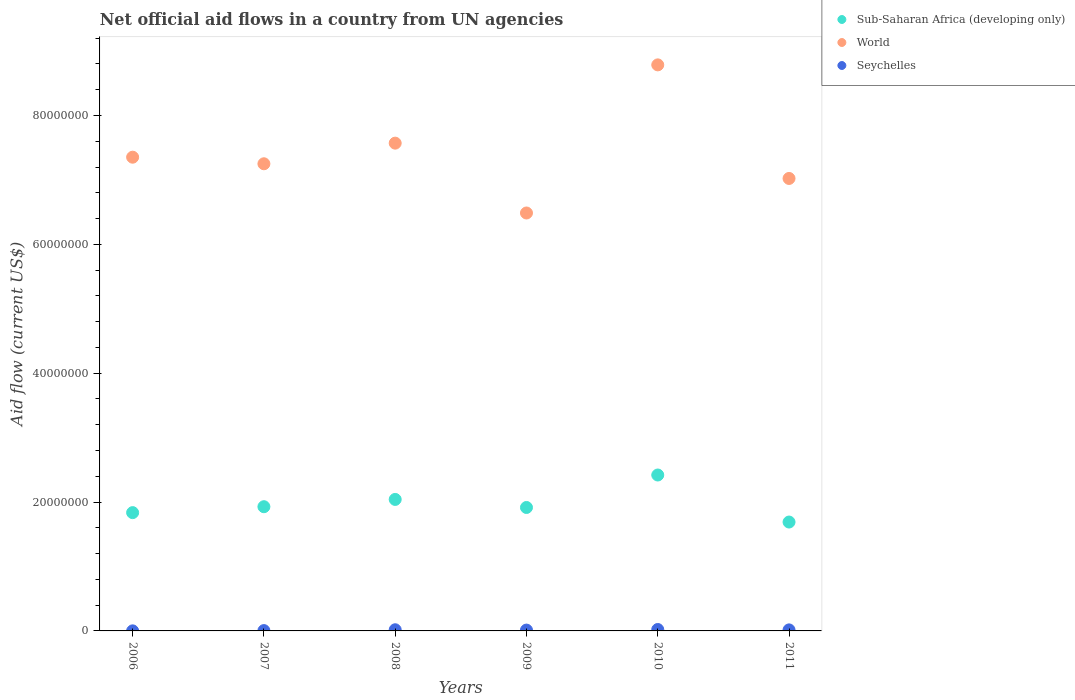How many different coloured dotlines are there?
Provide a succinct answer. 3. Is the number of dotlines equal to the number of legend labels?
Provide a succinct answer. Yes. What is the net official aid flow in World in 2011?
Give a very brief answer. 7.02e+07. Across all years, what is the maximum net official aid flow in Seychelles?
Your answer should be compact. 2.20e+05. Across all years, what is the minimum net official aid flow in Sub-Saharan Africa (developing only)?
Make the answer very short. 1.69e+07. In which year was the net official aid flow in Seychelles minimum?
Ensure brevity in your answer.  2006. What is the total net official aid flow in Seychelles in the graph?
Provide a short and direct response. 7.50e+05. What is the difference between the net official aid flow in Sub-Saharan Africa (developing only) in 2006 and that in 2009?
Your answer should be compact. -8.00e+05. What is the difference between the net official aid flow in Seychelles in 2006 and the net official aid flow in World in 2011?
Your answer should be very brief. -7.02e+07. What is the average net official aid flow in Sub-Saharan Africa (developing only) per year?
Your response must be concise. 1.97e+07. In the year 2011, what is the difference between the net official aid flow in Seychelles and net official aid flow in Sub-Saharan Africa (developing only)?
Your answer should be very brief. -1.67e+07. In how many years, is the net official aid flow in World greater than 84000000 US$?
Provide a short and direct response. 1. What is the ratio of the net official aid flow in Seychelles in 2009 to that in 2011?
Your answer should be compact. 0.81. What is the difference between the highest and the second highest net official aid flow in Seychelles?
Keep it short and to the point. 4.00e+04. What is the difference between the highest and the lowest net official aid flow in World?
Provide a short and direct response. 2.30e+07. Is it the case that in every year, the sum of the net official aid flow in World and net official aid flow in Seychelles  is greater than the net official aid flow in Sub-Saharan Africa (developing only)?
Provide a short and direct response. Yes. Is the net official aid flow in World strictly less than the net official aid flow in Sub-Saharan Africa (developing only) over the years?
Your response must be concise. No. How many dotlines are there?
Your response must be concise. 3. What is the difference between two consecutive major ticks on the Y-axis?
Give a very brief answer. 2.00e+07. Are the values on the major ticks of Y-axis written in scientific E-notation?
Give a very brief answer. No. Does the graph contain grids?
Offer a terse response. No. How many legend labels are there?
Provide a succinct answer. 3. How are the legend labels stacked?
Give a very brief answer. Vertical. What is the title of the graph?
Ensure brevity in your answer.  Net official aid flows in a country from UN agencies. Does "South Africa" appear as one of the legend labels in the graph?
Your answer should be compact. No. What is the label or title of the Y-axis?
Provide a short and direct response. Aid flow (current US$). What is the Aid flow (current US$) of Sub-Saharan Africa (developing only) in 2006?
Your answer should be compact. 1.84e+07. What is the Aid flow (current US$) in World in 2006?
Your answer should be compact. 7.35e+07. What is the Aid flow (current US$) of Sub-Saharan Africa (developing only) in 2007?
Provide a succinct answer. 1.93e+07. What is the Aid flow (current US$) of World in 2007?
Give a very brief answer. 7.25e+07. What is the Aid flow (current US$) in Seychelles in 2007?
Keep it short and to the point. 5.00e+04. What is the Aid flow (current US$) of Sub-Saharan Africa (developing only) in 2008?
Offer a terse response. 2.04e+07. What is the Aid flow (current US$) of World in 2008?
Make the answer very short. 7.57e+07. What is the Aid flow (current US$) of Seychelles in 2008?
Provide a succinct answer. 1.80e+05. What is the Aid flow (current US$) in Sub-Saharan Africa (developing only) in 2009?
Your answer should be very brief. 1.92e+07. What is the Aid flow (current US$) in World in 2009?
Your response must be concise. 6.49e+07. What is the Aid flow (current US$) in Seychelles in 2009?
Offer a terse response. 1.30e+05. What is the Aid flow (current US$) of Sub-Saharan Africa (developing only) in 2010?
Your answer should be compact. 2.42e+07. What is the Aid flow (current US$) of World in 2010?
Provide a short and direct response. 8.79e+07. What is the Aid flow (current US$) in Seychelles in 2010?
Your answer should be compact. 2.20e+05. What is the Aid flow (current US$) of Sub-Saharan Africa (developing only) in 2011?
Your answer should be very brief. 1.69e+07. What is the Aid flow (current US$) in World in 2011?
Offer a very short reply. 7.02e+07. Across all years, what is the maximum Aid flow (current US$) in Sub-Saharan Africa (developing only)?
Give a very brief answer. 2.42e+07. Across all years, what is the maximum Aid flow (current US$) of World?
Your response must be concise. 8.79e+07. Across all years, what is the maximum Aid flow (current US$) of Seychelles?
Offer a terse response. 2.20e+05. Across all years, what is the minimum Aid flow (current US$) of Sub-Saharan Africa (developing only)?
Your answer should be compact. 1.69e+07. Across all years, what is the minimum Aid flow (current US$) of World?
Offer a terse response. 6.49e+07. What is the total Aid flow (current US$) in Sub-Saharan Africa (developing only) in the graph?
Give a very brief answer. 1.18e+08. What is the total Aid flow (current US$) in World in the graph?
Offer a terse response. 4.45e+08. What is the total Aid flow (current US$) of Seychelles in the graph?
Your answer should be very brief. 7.50e+05. What is the difference between the Aid flow (current US$) of Sub-Saharan Africa (developing only) in 2006 and that in 2007?
Provide a short and direct response. -9.20e+05. What is the difference between the Aid flow (current US$) in World in 2006 and that in 2007?
Your response must be concise. 1.02e+06. What is the difference between the Aid flow (current US$) of Sub-Saharan Africa (developing only) in 2006 and that in 2008?
Ensure brevity in your answer.  -2.05e+06. What is the difference between the Aid flow (current US$) in World in 2006 and that in 2008?
Your answer should be very brief. -2.18e+06. What is the difference between the Aid flow (current US$) in Seychelles in 2006 and that in 2008?
Provide a succinct answer. -1.70e+05. What is the difference between the Aid flow (current US$) in Sub-Saharan Africa (developing only) in 2006 and that in 2009?
Your answer should be compact. -8.00e+05. What is the difference between the Aid flow (current US$) in World in 2006 and that in 2009?
Offer a terse response. 8.66e+06. What is the difference between the Aid flow (current US$) of Seychelles in 2006 and that in 2009?
Offer a very short reply. -1.20e+05. What is the difference between the Aid flow (current US$) of Sub-Saharan Africa (developing only) in 2006 and that in 2010?
Keep it short and to the point. -5.84e+06. What is the difference between the Aid flow (current US$) in World in 2006 and that in 2010?
Offer a very short reply. -1.43e+07. What is the difference between the Aid flow (current US$) of Sub-Saharan Africa (developing only) in 2006 and that in 2011?
Ensure brevity in your answer.  1.46e+06. What is the difference between the Aid flow (current US$) of World in 2006 and that in 2011?
Your answer should be compact. 3.30e+06. What is the difference between the Aid flow (current US$) of Seychelles in 2006 and that in 2011?
Offer a very short reply. -1.50e+05. What is the difference between the Aid flow (current US$) in Sub-Saharan Africa (developing only) in 2007 and that in 2008?
Ensure brevity in your answer.  -1.13e+06. What is the difference between the Aid flow (current US$) of World in 2007 and that in 2008?
Ensure brevity in your answer.  -3.20e+06. What is the difference between the Aid flow (current US$) of Seychelles in 2007 and that in 2008?
Keep it short and to the point. -1.30e+05. What is the difference between the Aid flow (current US$) of World in 2007 and that in 2009?
Your answer should be very brief. 7.64e+06. What is the difference between the Aid flow (current US$) in Seychelles in 2007 and that in 2009?
Your answer should be very brief. -8.00e+04. What is the difference between the Aid flow (current US$) in Sub-Saharan Africa (developing only) in 2007 and that in 2010?
Ensure brevity in your answer.  -4.92e+06. What is the difference between the Aid flow (current US$) in World in 2007 and that in 2010?
Provide a succinct answer. -1.54e+07. What is the difference between the Aid flow (current US$) in Sub-Saharan Africa (developing only) in 2007 and that in 2011?
Offer a very short reply. 2.38e+06. What is the difference between the Aid flow (current US$) in World in 2007 and that in 2011?
Offer a terse response. 2.28e+06. What is the difference between the Aid flow (current US$) of Sub-Saharan Africa (developing only) in 2008 and that in 2009?
Give a very brief answer. 1.25e+06. What is the difference between the Aid flow (current US$) in World in 2008 and that in 2009?
Make the answer very short. 1.08e+07. What is the difference between the Aid flow (current US$) in Seychelles in 2008 and that in 2009?
Provide a short and direct response. 5.00e+04. What is the difference between the Aid flow (current US$) in Sub-Saharan Africa (developing only) in 2008 and that in 2010?
Offer a terse response. -3.79e+06. What is the difference between the Aid flow (current US$) of World in 2008 and that in 2010?
Offer a very short reply. -1.22e+07. What is the difference between the Aid flow (current US$) in Seychelles in 2008 and that in 2010?
Your answer should be very brief. -4.00e+04. What is the difference between the Aid flow (current US$) of Sub-Saharan Africa (developing only) in 2008 and that in 2011?
Provide a succinct answer. 3.51e+06. What is the difference between the Aid flow (current US$) in World in 2008 and that in 2011?
Provide a succinct answer. 5.48e+06. What is the difference between the Aid flow (current US$) of Seychelles in 2008 and that in 2011?
Your answer should be compact. 2.00e+04. What is the difference between the Aid flow (current US$) in Sub-Saharan Africa (developing only) in 2009 and that in 2010?
Offer a terse response. -5.04e+06. What is the difference between the Aid flow (current US$) in World in 2009 and that in 2010?
Give a very brief answer. -2.30e+07. What is the difference between the Aid flow (current US$) of Seychelles in 2009 and that in 2010?
Give a very brief answer. -9.00e+04. What is the difference between the Aid flow (current US$) in Sub-Saharan Africa (developing only) in 2009 and that in 2011?
Your response must be concise. 2.26e+06. What is the difference between the Aid flow (current US$) of World in 2009 and that in 2011?
Offer a very short reply. -5.36e+06. What is the difference between the Aid flow (current US$) of Seychelles in 2009 and that in 2011?
Your answer should be compact. -3.00e+04. What is the difference between the Aid flow (current US$) of Sub-Saharan Africa (developing only) in 2010 and that in 2011?
Your response must be concise. 7.30e+06. What is the difference between the Aid flow (current US$) of World in 2010 and that in 2011?
Provide a short and direct response. 1.76e+07. What is the difference between the Aid flow (current US$) in Sub-Saharan Africa (developing only) in 2006 and the Aid flow (current US$) in World in 2007?
Give a very brief answer. -5.42e+07. What is the difference between the Aid flow (current US$) in Sub-Saharan Africa (developing only) in 2006 and the Aid flow (current US$) in Seychelles in 2007?
Provide a short and direct response. 1.83e+07. What is the difference between the Aid flow (current US$) in World in 2006 and the Aid flow (current US$) in Seychelles in 2007?
Provide a short and direct response. 7.35e+07. What is the difference between the Aid flow (current US$) in Sub-Saharan Africa (developing only) in 2006 and the Aid flow (current US$) in World in 2008?
Your answer should be very brief. -5.74e+07. What is the difference between the Aid flow (current US$) of Sub-Saharan Africa (developing only) in 2006 and the Aid flow (current US$) of Seychelles in 2008?
Offer a very short reply. 1.82e+07. What is the difference between the Aid flow (current US$) of World in 2006 and the Aid flow (current US$) of Seychelles in 2008?
Your answer should be very brief. 7.34e+07. What is the difference between the Aid flow (current US$) of Sub-Saharan Africa (developing only) in 2006 and the Aid flow (current US$) of World in 2009?
Make the answer very short. -4.65e+07. What is the difference between the Aid flow (current US$) in Sub-Saharan Africa (developing only) in 2006 and the Aid flow (current US$) in Seychelles in 2009?
Make the answer very short. 1.82e+07. What is the difference between the Aid flow (current US$) of World in 2006 and the Aid flow (current US$) of Seychelles in 2009?
Ensure brevity in your answer.  7.34e+07. What is the difference between the Aid flow (current US$) of Sub-Saharan Africa (developing only) in 2006 and the Aid flow (current US$) of World in 2010?
Ensure brevity in your answer.  -6.95e+07. What is the difference between the Aid flow (current US$) of Sub-Saharan Africa (developing only) in 2006 and the Aid flow (current US$) of Seychelles in 2010?
Your answer should be very brief. 1.81e+07. What is the difference between the Aid flow (current US$) of World in 2006 and the Aid flow (current US$) of Seychelles in 2010?
Your answer should be very brief. 7.33e+07. What is the difference between the Aid flow (current US$) in Sub-Saharan Africa (developing only) in 2006 and the Aid flow (current US$) in World in 2011?
Give a very brief answer. -5.19e+07. What is the difference between the Aid flow (current US$) of Sub-Saharan Africa (developing only) in 2006 and the Aid flow (current US$) of Seychelles in 2011?
Offer a very short reply. 1.82e+07. What is the difference between the Aid flow (current US$) in World in 2006 and the Aid flow (current US$) in Seychelles in 2011?
Ensure brevity in your answer.  7.34e+07. What is the difference between the Aid flow (current US$) of Sub-Saharan Africa (developing only) in 2007 and the Aid flow (current US$) of World in 2008?
Give a very brief answer. -5.64e+07. What is the difference between the Aid flow (current US$) of Sub-Saharan Africa (developing only) in 2007 and the Aid flow (current US$) of Seychelles in 2008?
Provide a short and direct response. 1.91e+07. What is the difference between the Aid flow (current US$) of World in 2007 and the Aid flow (current US$) of Seychelles in 2008?
Provide a short and direct response. 7.23e+07. What is the difference between the Aid flow (current US$) of Sub-Saharan Africa (developing only) in 2007 and the Aid flow (current US$) of World in 2009?
Offer a very short reply. -4.56e+07. What is the difference between the Aid flow (current US$) of Sub-Saharan Africa (developing only) in 2007 and the Aid flow (current US$) of Seychelles in 2009?
Keep it short and to the point. 1.92e+07. What is the difference between the Aid flow (current US$) of World in 2007 and the Aid flow (current US$) of Seychelles in 2009?
Provide a succinct answer. 7.24e+07. What is the difference between the Aid flow (current US$) of Sub-Saharan Africa (developing only) in 2007 and the Aid flow (current US$) of World in 2010?
Your answer should be compact. -6.86e+07. What is the difference between the Aid flow (current US$) in Sub-Saharan Africa (developing only) in 2007 and the Aid flow (current US$) in Seychelles in 2010?
Provide a short and direct response. 1.91e+07. What is the difference between the Aid flow (current US$) of World in 2007 and the Aid flow (current US$) of Seychelles in 2010?
Give a very brief answer. 7.23e+07. What is the difference between the Aid flow (current US$) in Sub-Saharan Africa (developing only) in 2007 and the Aid flow (current US$) in World in 2011?
Offer a terse response. -5.10e+07. What is the difference between the Aid flow (current US$) in Sub-Saharan Africa (developing only) in 2007 and the Aid flow (current US$) in Seychelles in 2011?
Your answer should be compact. 1.91e+07. What is the difference between the Aid flow (current US$) of World in 2007 and the Aid flow (current US$) of Seychelles in 2011?
Your response must be concise. 7.24e+07. What is the difference between the Aid flow (current US$) in Sub-Saharan Africa (developing only) in 2008 and the Aid flow (current US$) in World in 2009?
Keep it short and to the point. -4.45e+07. What is the difference between the Aid flow (current US$) of Sub-Saharan Africa (developing only) in 2008 and the Aid flow (current US$) of Seychelles in 2009?
Keep it short and to the point. 2.03e+07. What is the difference between the Aid flow (current US$) in World in 2008 and the Aid flow (current US$) in Seychelles in 2009?
Provide a short and direct response. 7.56e+07. What is the difference between the Aid flow (current US$) of Sub-Saharan Africa (developing only) in 2008 and the Aid flow (current US$) of World in 2010?
Provide a succinct answer. -6.74e+07. What is the difference between the Aid flow (current US$) in Sub-Saharan Africa (developing only) in 2008 and the Aid flow (current US$) in Seychelles in 2010?
Make the answer very short. 2.02e+07. What is the difference between the Aid flow (current US$) of World in 2008 and the Aid flow (current US$) of Seychelles in 2010?
Provide a short and direct response. 7.55e+07. What is the difference between the Aid flow (current US$) in Sub-Saharan Africa (developing only) in 2008 and the Aid flow (current US$) in World in 2011?
Offer a very short reply. -4.98e+07. What is the difference between the Aid flow (current US$) in Sub-Saharan Africa (developing only) in 2008 and the Aid flow (current US$) in Seychelles in 2011?
Your response must be concise. 2.02e+07. What is the difference between the Aid flow (current US$) in World in 2008 and the Aid flow (current US$) in Seychelles in 2011?
Your answer should be compact. 7.56e+07. What is the difference between the Aid flow (current US$) of Sub-Saharan Africa (developing only) in 2009 and the Aid flow (current US$) of World in 2010?
Ensure brevity in your answer.  -6.87e+07. What is the difference between the Aid flow (current US$) in Sub-Saharan Africa (developing only) in 2009 and the Aid flow (current US$) in Seychelles in 2010?
Your response must be concise. 1.89e+07. What is the difference between the Aid flow (current US$) of World in 2009 and the Aid flow (current US$) of Seychelles in 2010?
Your answer should be compact. 6.46e+07. What is the difference between the Aid flow (current US$) in Sub-Saharan Africa (developing only) in 2009 and the Aid flow (current US$) in World in 2011?
Your response must be concise. -5.11e+07. What is the difference between the Aid flow (current US$) of Sub-Saharan Africa (developing only) in 2009 and the Aid flow (current US$) of Seychelles in 2011?
Offer a very short reply. 1.90e+07. What is the difference between the Aid flow (current US$) in World in 2009 and the Aid flow (current US$) in Seychelles in 2011?
Provide a succinct answer. 6.47e+07. What is the difference between the Aid flow (current US$) in Sub-Saharan Africa (developing only) in 2010 and the Aid flow (current US$) in World in 2011?
Provide a short and direct response. -4.60e+07. What is the difference between the Aid flow (current US$) in Sub-Saharan Africa (developing only) in 2010 and the Aid flow (current US$) in Seychelles in 2011?
Offer a very short reply. 2.40e+07. What is the difference between the Aid flow (current US$) in World in 2010 and the Aid flow (current US$) in Seychelles in 2011?
Your answer should be very brief. 8.77e+07. What is the average Aid flow (current US$) of Sub-Saharan Africa (developing only) per year?
Provide a succinct answer. 1.97e+07. What is the average Aid flow (current US$) in World per year?
Offer a terse response. 7.41e+07. What is the average Aid flow (current US$) in Seychelles per year?
Offer a terse response. 1.25e+05. In the year 2006, what is the difference between the Aid flow (current US$) of Sub-Saharan Africa (developing only) and Aid flow (current US$) of World?
Ensure brevity in your answer.  -5.52e+07. In the year 2006, what is the difference between the Aid flow (current US$) in Sub-Saharan Africa (developing only) and Aid flow (current US$) in Seychelles?
Offer a terse response. 1.84e+07. In the year 2006, what is the difference between the Aid flow (current US$) in World and Aid flow (current US$) in Seychelles?
Offer a terse response. 7.35e+07. In the year 2007, what is the difference between the Aid flow (current US$) of Sub-Saharan Africa (developing only) and Aid flow (current US$) of World?
Your answer should be very brief. -5.32e+07. In the year 2007, what is the difference between the Aid flow (current US$) of Sub-Saharan Africa (developing only) and Aid flow (current US$) of Seychelles?
Make the answer very short. 1.92e+07. In the year 2007, what is the difference between the Aid flow (current US$) of World and Aid flow (current US$) of Seychelles?
Offer a very short reply. 7.25e+07. In the year 2008, what is the difference between the Aid flow (current US$) in Sub-Saharan Africa (developing only) and Aid flow (current US$) in World?
Keep it short and to the point. -5.53e+07. In the year 2008, what is the difference between the Aid flow (current US$) in Sub-Saharan Africa (developing only) and Aid flow (current US$) in Seychelles?
Provide a succinct answer. 2.02e+07. In the year 2008, what is the difference between the Aid flow (current US$) of World and Aid flow (current US$) of Seychelles?
Offer a terse response. 7.55e+07. In the year 2009, what is the difference between the Aid flow (current US$) in Sub-Saharan Africa (developing only) and Aid flow (current US$) in World?
Provide a short and direct response. -4.57e+07. In the year 2009, what is the difference between the Aid flow (current US$) in Sub-Saharan Africa (developing only) and Aid flow (current US$) in Seychelles?
Offer a very short reply. 1.90e+07. In the year 2009, what is the difference between the Aid flow (current US$) in World and Aid flow (current US$) in Seychelles?
Offer a terse response. 6.47e+07. In the year 2010, what is the difference between the Aid flow (current US$) in Sub-Saharan Africa (developing only) and Aid flow (current US$) in World?
Provide a succinct answer. -6.37e+07. In the year 2010, what is the difference between the Aid flow (current US$) in Sub-Saharan Africa (developing only) and Aid flow (current US$) in Seychelles?
Your response must be concise. 2.40e+07. In the year 2010, what is the difference between the Aid flow (current US$) of World and Aid flow (current US$) of Seychelles?
Provide a succinct answer. 8.76e+07. In the year 2011, what is the difference between the Aid flow (current US$) in Sub-Saharan Africa (developing only) and Aid flow (current US$) in World?
Provide a succinct answer. -5.33e+07. In the year 2011, what is the difference between the Aid flow (current US$) of Sub-Saharan Africa (developing only) and Aid flow (current US$) of Seychelles?
Ensure brevity in your answer.  1.67e+07. In the year 2011, what is the difference between the Aid flow (current US$) in World and Aid flow (current US$) in Seychelles?
Ensure brevity in your answer.  7.01e+07. What is the ratio of the Aid flow (current US$) of Sub-Saharan Africa (developing only) in 2006 to that in 2007?
Give a very brief answer. 0.95. What is the ratio of the Aid flow (current US$) of World in 2006 to that in 2007?
Keep it short and to the point. 1.01. What is the ratio of the Aid flow (current US$) of Seychelles in 2006 to that in 2007?
Your answer should be compact. 0.2. What is the ratio of the Aid flow (current US$) in Sub-Saharan Africa (developing only) in 2006 to that in 2008?
Offer a terse response. 0.9. What is the ratio of the Aid flow (current US$) of World in 2006 to that in 2008?
Ensure brevity in your answer.  0.97. What is the ratio of the Aid flow (current US$) of Seychelles in 2006 to that in 2008?
Your response must be concise. 0.06. What is the ratio of the Aid flow (current US$) of Sub-Saharan Africa (developing only) in 2006 to that in 2009?
Your response must be concise. 0.96. What is the ratio of the Aid flow (current US$) in World in 2006 to that in 2009?
Provide a succinct answer. 1.13. What is the ratio of the Aid flow (current US$) in Seychelles in 2006 to that in 2009?
Provide a succinct answer. 0.08. What is the ratio of the Aid flow (current US$) of Sub-Saharan Africa (developing only) in 2006 to that in 2010?
Offer a very short reply. 0.76. What is the ratio of the Aid flow (current US$) in World in 2006 to that in 2010?
Offer a terse response. 0.84. What is the ratio of the Aid flow (current US$) of Seychelles in 2006 to that in 2010?
Provide a succinct answer. 0.05. What is the ratio of the Aid flow (current US$) in Sub-Saharan Africa (developing only) in 2006 to that in 2011?
Provide a succinct answer. 1.09. What is the ratio of the Aid flow (current US$) of World in 2006 to that in 2011?
Give a very brief answer. 1.05. What is the ratio of the Aid flow (current US$) of Seychelles in 2006 to that in 2011?
Make the answer very short. 0.06. What is the ratio of the Aid flow (current US$) in Sub-Saharan Africa (developing only) in 2007 to that in 2008?
Provide a short and direct response. 0.94. What is the ratio of the Aid flow (current US$) in World in 2007 to that in 2008?
Your response must be concise. 0.96. What is the ratio of the Aid flow (current US$) of Seychelles in 2007 to that in 2008?
Provide a short and direct response. 0.28. What is the ratio of the Aid flow (current US$) of World in 2007 to that in 2009?
Provide a succinct answer. 1.12. What is the ratio of the Aid flow (current US$) in Seychelles in 2007 to that in 2009?
Your answer should be compact. 0.38. What is the ratio of the Aid flow (current US$) of Sub-Saharan Africa (developing only) in 2007 to that in 2010?
Provide a succinct answer. 0.8. What is the ratio of the Aid flow (current US$) of World in 2007 to that in 2010?
Offer a very short reply. 0.83. What is the ratio of the Aid flow (current US$) in Seychelles in 2007 to that in 2010?
Provide a succinct answer. 0.23. What is the ratio of the Aid flow (current US$) of Sub-Saharan Africa (developing only) in 2007 to that in 2011?
Ensure brevity in your answer.  1.14. What is the ratio of the Aid flow (current US$) of World in 2007 to that in 2011?
Offer a very short reply. 1.03. What is the ratio of the Aid flow (current US$) in Seychelles in 2007 to that in 2011?
Keep it short and to the point. 0.31. What is the ratio of the Aid flow (current US$) in Sub-Saharan Africa (developing only) in 2008 to that in 2009?
Offer a terse response. 1.07. What is the ratio of the Aid flow (current US$) of World in 2008 to that in 2009?
Ensure brevity in your answer.  1.17. What is the ratio of the Aid flow (current US$) of Seychelles in 2008 to that in 2009?
Provide a succinct answer. 1.38. What is the ratio of the Aid flow (current US$) in Sub-Saharan Africa (developing only) in 2008 to that in 2010?
Provide a short and direct response. 0.84. What is the ratio of the Aid flow (current US$) of World in 2008 to that in 2010?
Provide a succinct answer. 0.86. What is the ratio of the Aid flow (current US$) in Seychelles in 2008 to that in 2010?
Ensure brevity in your answer.  0.82. What is the ratio of the Aid flow (current US$) in Sub-Saharan Africa (developing only) in 2008 to that in 2011?
Your answer should be compact. 1.21. What is the ratio of the Aid flow (current US$) of World in 2008 to that in 2011?
Make the answer very short. 1.08. What is the ratio of the Aid flow (current US$) of Seychelles in 2008 to that in 2011?
Offer a terse response. 1.12. What is the ratio of the Aid flow (current US$) of Sub-Saharan Africa (developing only) in 2009 to that in 2010?
Give a very brief answer. 0.79. What is the ratio of the Aid flow (current US$) of World in 2009 to that in 2010?
Keep it short and to the point. 0.74. What is the ratio of the Aid flow (current US$) in Seychelles in 2009 to that in 2010?
Keep it short and to the point. 0.59. What is the ratio of the Aid flow (current US$) in Sub-Saharan Africa (developing only) in 2009 to that in 2011?
Keep it short and to the point. 1.13. What is the ratio of the Aid flow (current US$) of World in 2009 to that in 2011?
Provide a short and direct response. 0.92. What is the ratio of the Aid flow (current US$) of Seychelles in 2009 to that in 2011?
Keep it short and to the point. 0.81. What is the ratio of the Aid flow (current US$) of Sub-Saharan Africa (developing only) in 2010 to that in 2011?
Ensure brevity in your answer.  1.43. What is the ratio of the Aid flow (current US$) in World in 2010 to that in 2011?
Your response must be concise. 1.25. What is the ratio of the Aid flow (current US$) of Seychelles in 2010 to that in 2011?
Provide a succinct answer. 1.38. What is the difference between the highest and the second highest Aid flow (current US$) in Sub-Saharan Africa (developing only)?
Keep it short and to the point. 3.79e+06. What is the difference between the highest and the second highest Aid flow (current US$) of World?
Keep it short and to the point. 1.22e+07. What is the difference between the highest and the second highest Aid flow (current US$) of Seychelles?
Your response must be concise. 4.00e+04. What is the difference between the highest and the lowest Aid flow (current US$) in Sub-Saharan Africa (developing only)?
Offer a terse response. 7.30e+06. What is the difference between the highest and the lowest Aid flow (current US$) in World?
Your answer should be compact. 2.30e+07. 